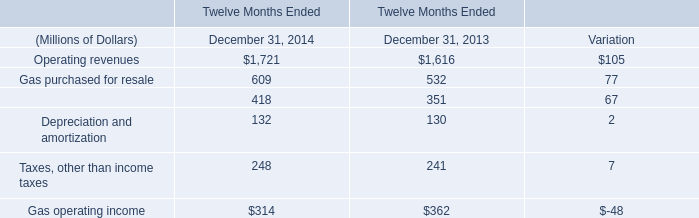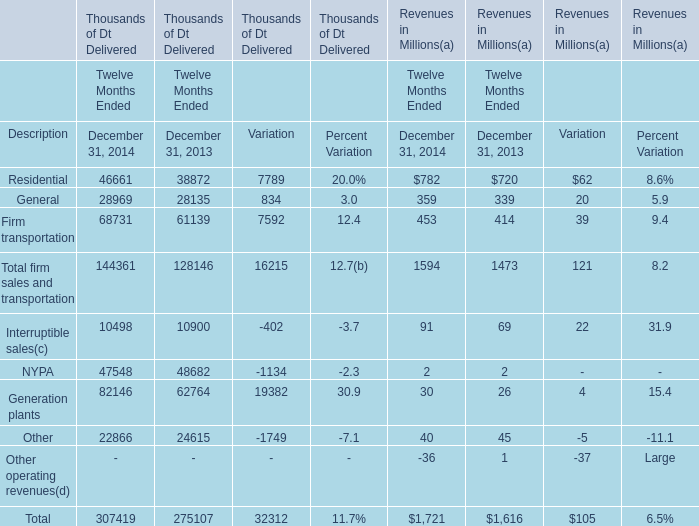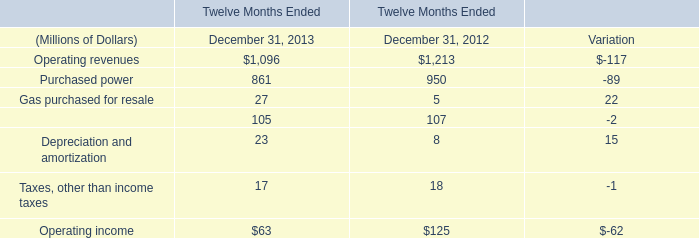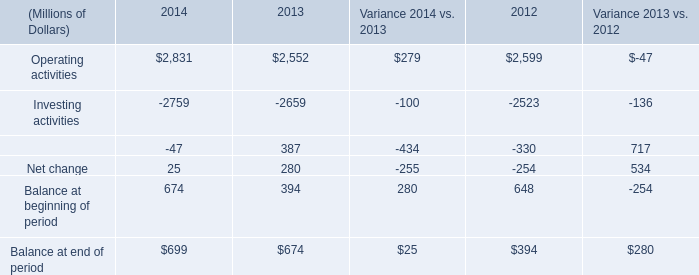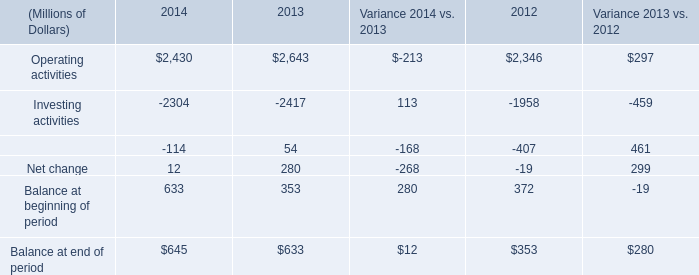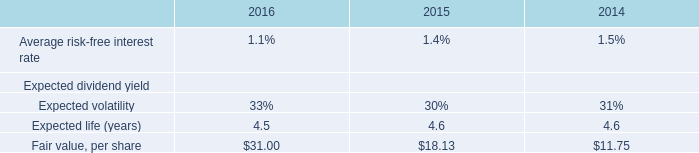what is the percentage difference in the fair value per share between 2015 and 2016? 
Computations: ((31 - 18.13) / 18.13)
Answer: 0.70987. 